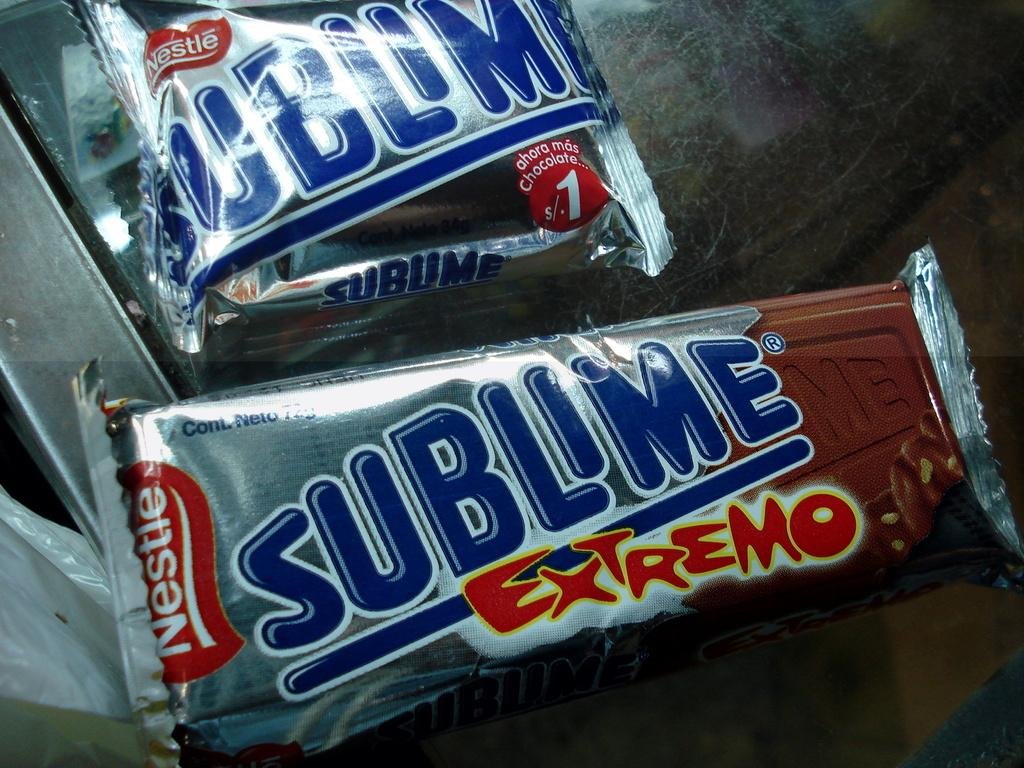<image>
Give a short and clear explanation of the subsequent image. two nestle sublime extremo candy bars in silver wrappers 